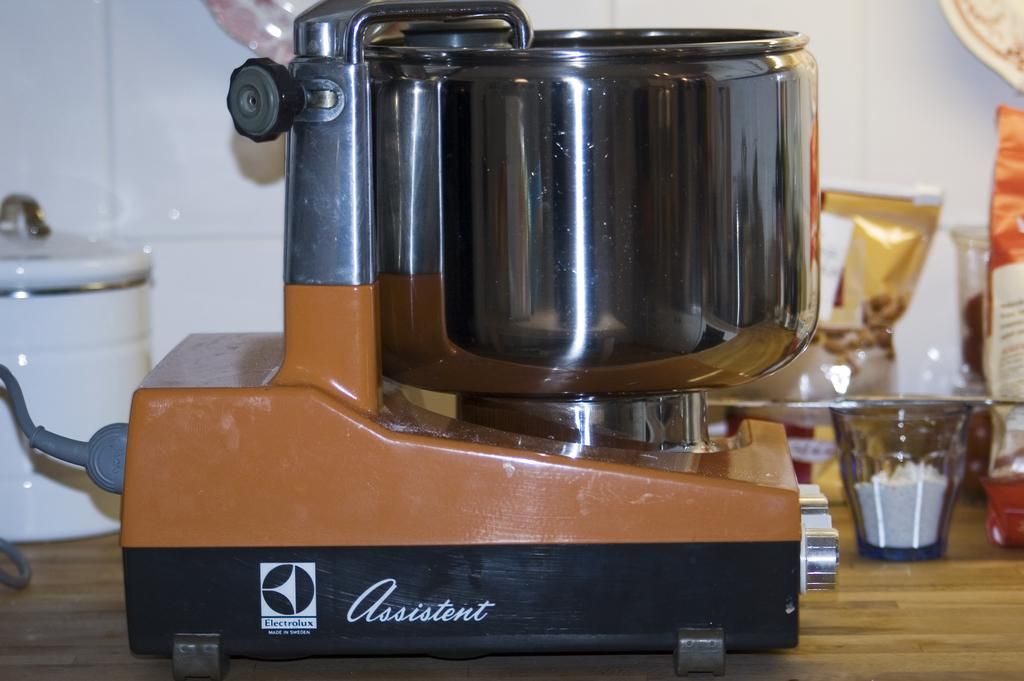<image>
Describe the image concisely. An old Electrolux assistent pressure cooker sits on a counter 